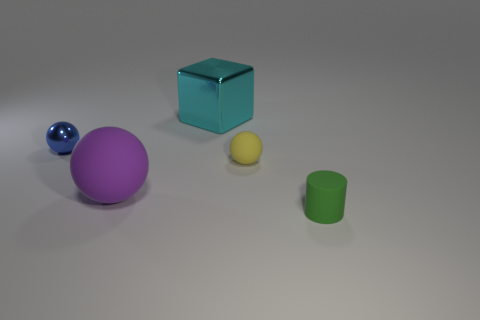There is another small object that is made of the same material as the yellow thing; what is its color?
Your answer should be very brief. Green. There is a ball behind the small matte object behind the green rubber cylinder on the right side of the cyan metallic block; what size is it?
Your answer should be very brief. Small. Is the number of big cyan cylinders less than the number of large blocks?
Provide a short and direct response. Yes. The large rubber thing that is the same shape as the small yellow object is what color?
Your response must be concise. Purple. Is there a large cube that is behind the tiny thing that is behind the tiny rubber thing that is behind the large purple ball?
Keep it short and to the point. Yes. Is the small blue shiny thing the same shape as the small yellow object?
Make the answer very short. Yes. Are there fewer yellow matte balls that are on the left side of the tiny blue metal sphere than big blue metallic spheres?
Offer a very short reply. No. What color is the small rubber thing left of the small matte thing in front of the purple ball that is right of the small blue metal sphere?
Make the answer very short. Yellow. What number of metal things are either cylinders or large yellow cubes?
Your response must be concise. 0. Do the blue sphere and the matte cylinder have the same size?
Your response must be concise. Yes. 